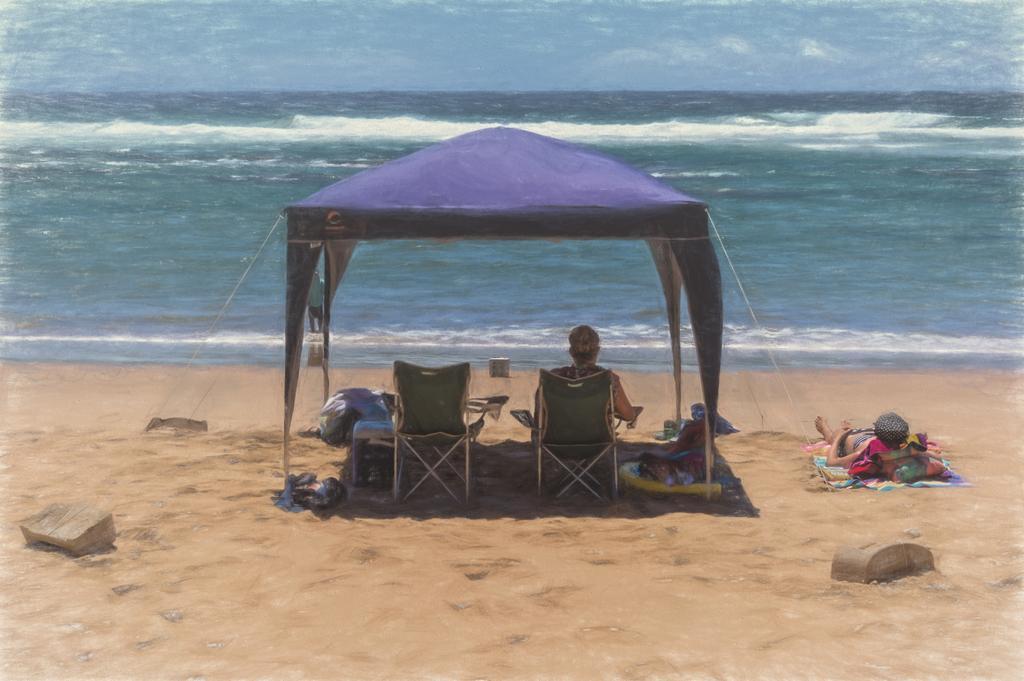In one or two sentences, can you explain what this image depicts? In this image we can see three persons, one of them is lying on the mat, another person is sitting on the chair, there is a tent, clothes, bags, and another chair, there are rocks, also we can see the ocean, and a person is walking on the seashore. 